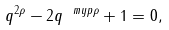<formula> <loc_0><loc_0><loc_500><loc_500>q ^ { 2 \rho } - 2 q ^ { \ m y p \rho } + 1 = 0 ,</formula> 